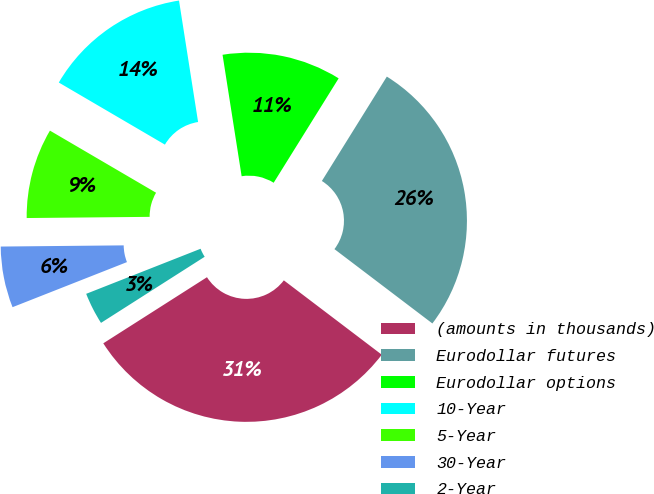Convert chart. <chart><loc_0><loc_0><loc_500><loc_500><pie_chart><fcel>(amounts in thousands)<fcel>Eurodollar futures<fcel>Eurodollar options<fcel>10-Year<fcel>5-Year<fcel>30-Year<fcel>2-Year<nl><fcel>30.63%<fcel>26.47%<fcel>11.34%<fcel>14.09%<fcel>8.58%<fcel>5.82%<fcel>3.06%<nl></chart> 